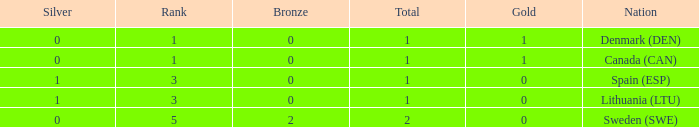How many bronze medals were won when the total is more than 1, and gold is more than 0? None. 